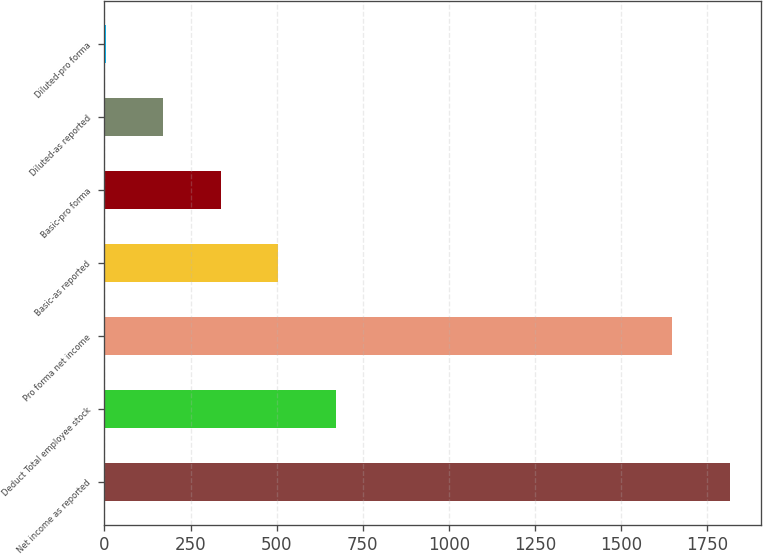<chart> <loc_0><loc_0><loc_500><loc_500><bar_chart><fcel>Net income as reported<fcel>Deduct Total employee stock<fcel>Pro forma net income<fcel>Basic-as reported<fcel>Basic-pro forma<fcel>Diluted-as reported<fcel>Diluted-pro forma<nl><fcel>1815.07<fcel>671.54<fcel>1648<fcel>504.47<fcel>337.4<fcel>170.33<fcel>3.26<nl></chart> 